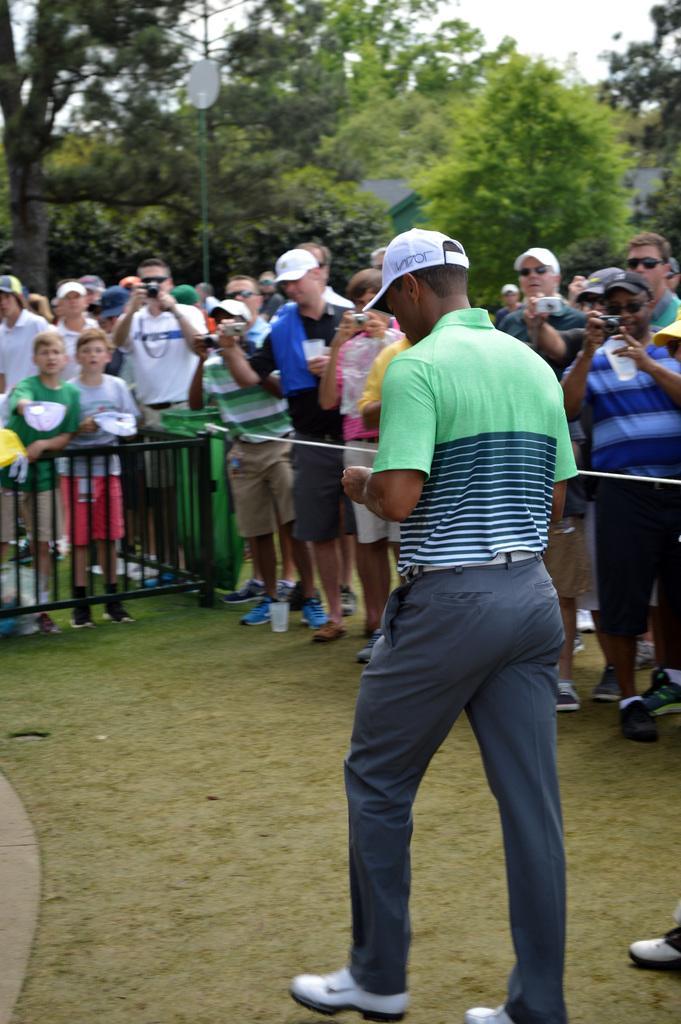In one or two sentences, can you explain what this image depicts? This image consists of many persons. Few are them are holding cameras and taking pictures. In the front, we can see a man standing is wearing a green T-shirt and a cap. At the bottom, there is green grass on the ground. In the background, there are trees. At the top, there is sky. 